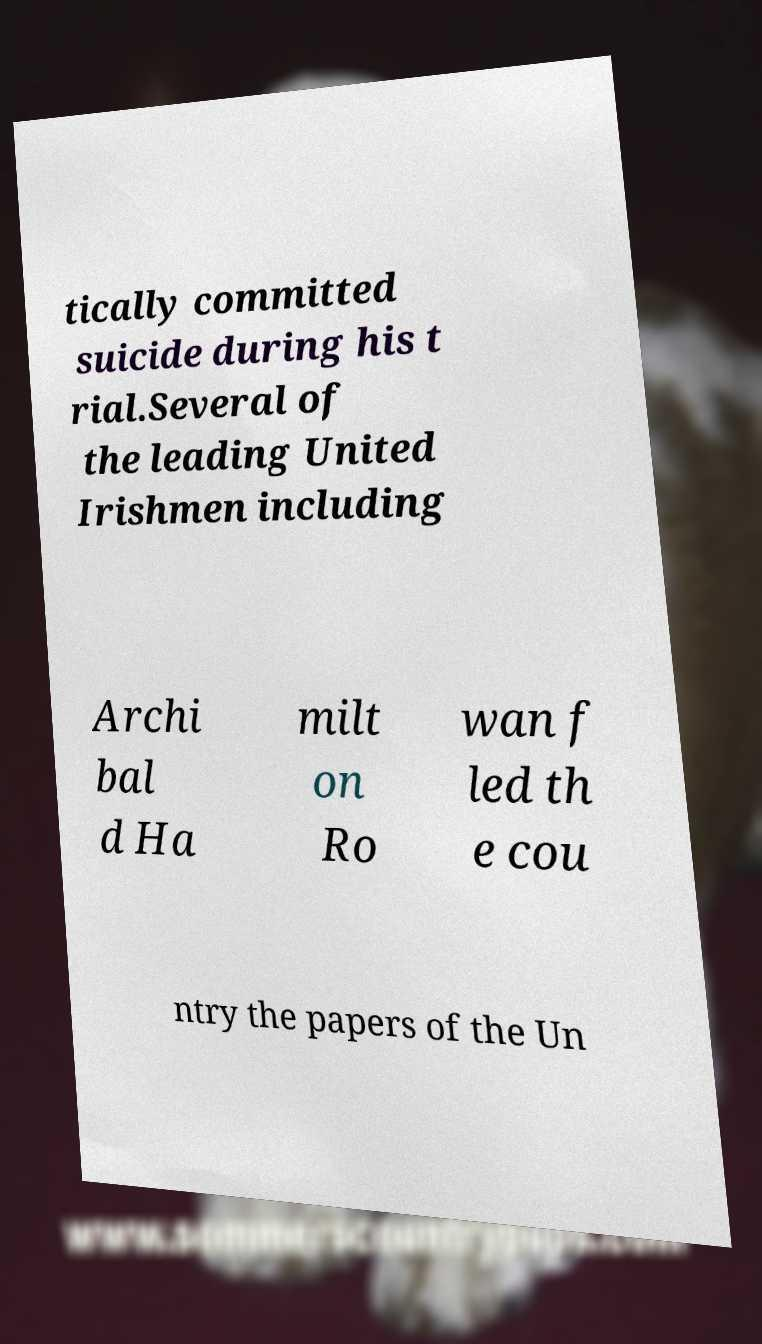I need the written content from this picture converted into text. Can you do that? tically committed suicide during his t rial.Several of the leading United Irishmen including Archi bal d Ha milt on Ro wan f led th e cou ntry the papers of the Un 